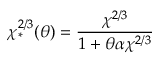<formula> <loc_0><loc_0><loc_500><loc_500>\chi _ { * } ^ { 2 / 3 } ( \theta ) = \frac { \chi ^ { 2 / 3 } } { 1 + \theta \alpha \chi ^ { 2 / 3 } }</formula> 